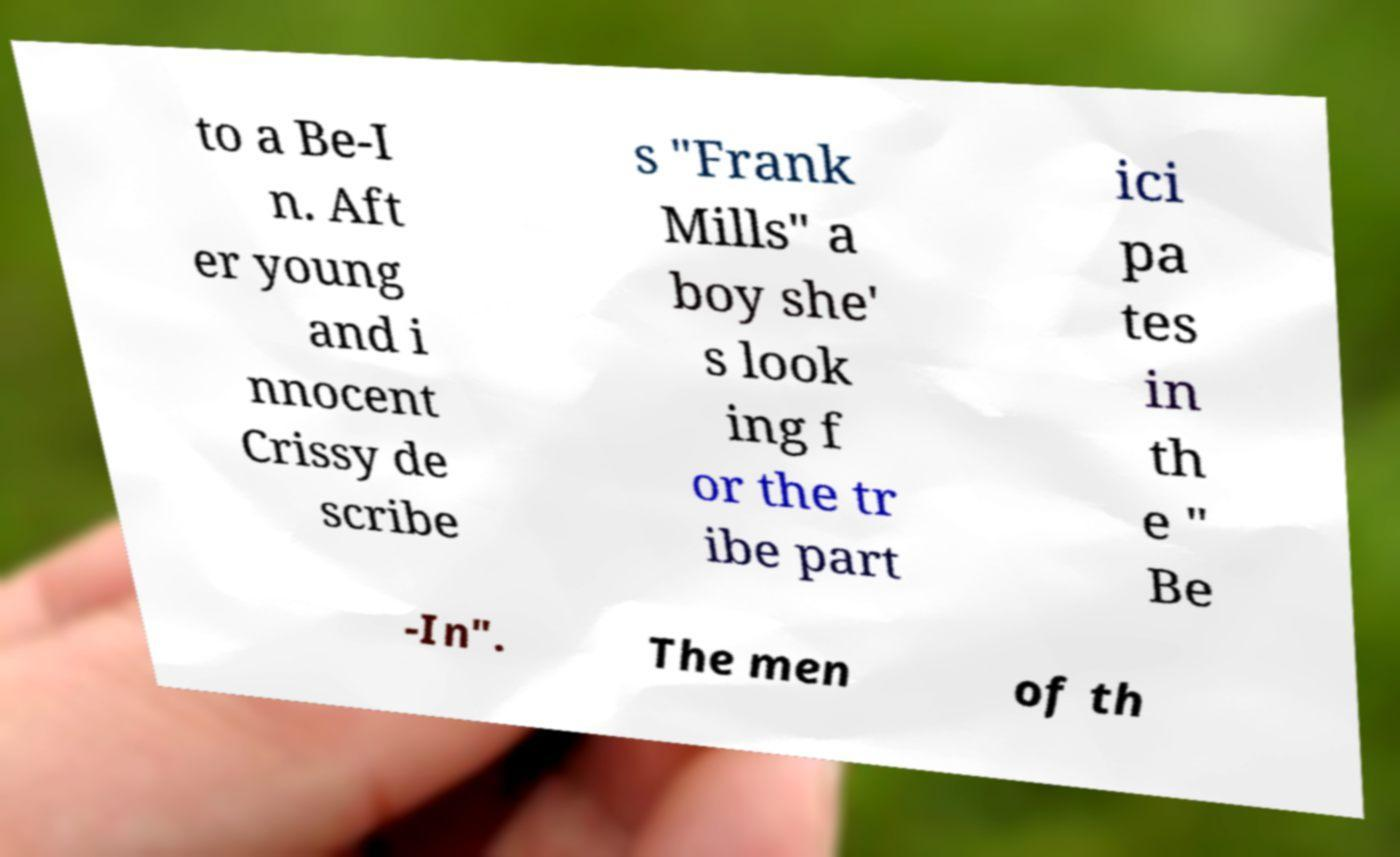Can you read and provide the text displayed in the image?This photo seems to have some interesting text. Can you extract and type it out for me? to a Be-I n. Aft er young and i nnocent Crissy de scribe s "Frank Mills" a boy she' s look ing f or the tr ibe part ici pa tes in th e " Be -In". The men of th 